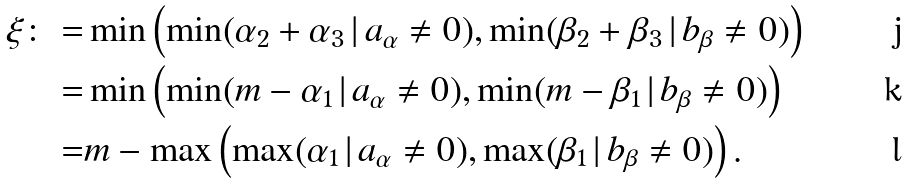<formula> <loc_0><loc_0><loc_500><loc_500>\xi \colon = & \min \left ( \min ( \alpha _ { 2 } + \alpha _ { 3 } \, | \, a _ { \alpha } \neq 0 ) , \min ( \beta _ { 2 } + \beta _ { 3 } \, | \, b _ { \beta } \neq 0 ) \right ) \\ = & \min \left ( \min ( m - \alpha _ { 1 } \, | \, a _ { \alpha } \neq 0 ) , \min ( m - \beta _ { 1 } \, | \, b _ { \beta } \neq 0 ) \right ) \\ = & m - \max \left ( \max ( \alpha _ { 1 } \, | \, a _ { \alpha } \neq 0 ) , \max ( \beta _ { 1 } \, | \, b _ { \beta } \neq 0 ) \right ) .</formula> 